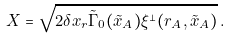Convert formula to latex. <formula><loc_0><loc_0><loc_500><loc_500>X = \sqrt { 2 \delta x _ { r } \tilde { \Gamma } _ { 0 } ( \tilde { x } _ { A } ) \xi ^ { \perp } ( r _ { A } , \tilde { x } _ { A } ) } \, .</formula> 